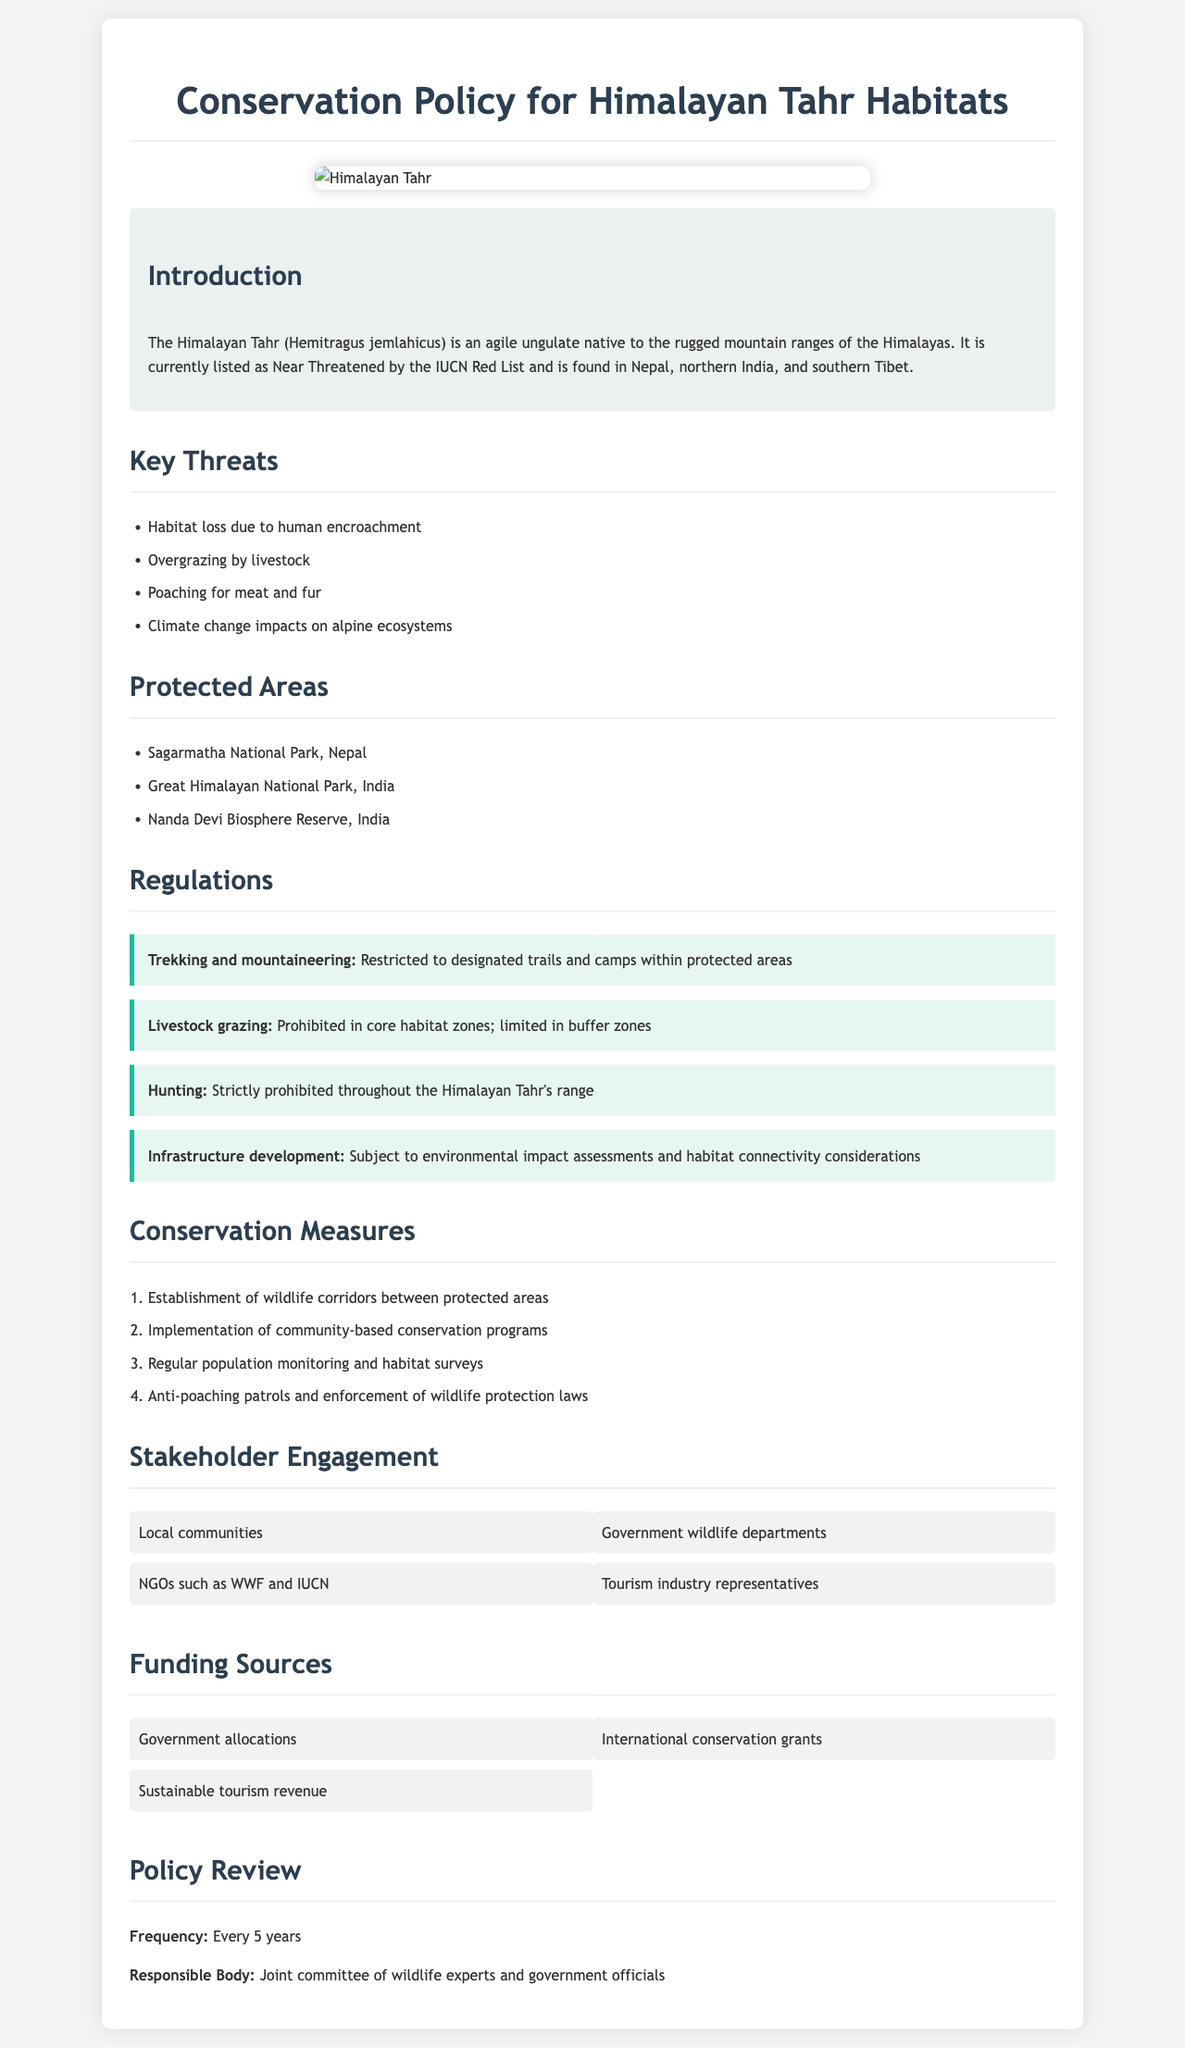What is the status of the Himalayan Tahr in the IUCN Red List? The document states that the Himalayan Tahr is currently listed as Near Threatened by the IUCN Red List.
Answer: Near Threatened Which national park is located in Nepal? The document lists Sagarmatha National Park as the protected area located in Nepal.
Answer: Sagarmatha National Park What are the regulations on hunting in the Himalayan Tahr's range? The document specifies that hunting is strictly prohibited throughout the Himalayan Tahr's range.
Answer: Strictly prohibited How often will the conservation policy be reviewed? The document states that the frequency of review is every 5 years.
Answer: Every 5 years What is one of the key threats to the Himalayan Tahr? The document lists habitat loss due to human encroachment as one of the key threats.
Answer: Habitat loss due to human encroachment What is prohibited in core habitat zones? The document mentions that livestock grazing is prohibited in core habitat zones.
Answer: Livestock grazing Which stakeholders are involved in the conservation efforts? The document lists local communities and government wildlife departments as stakeholders.
Answer: Local communities and government wildlife departments What are anti-poaching patrols aimed at? The document states that anti-poaching patrols aim at enforcing wildlife protection laws.
Answer: Enforcing wildlife protection laws 